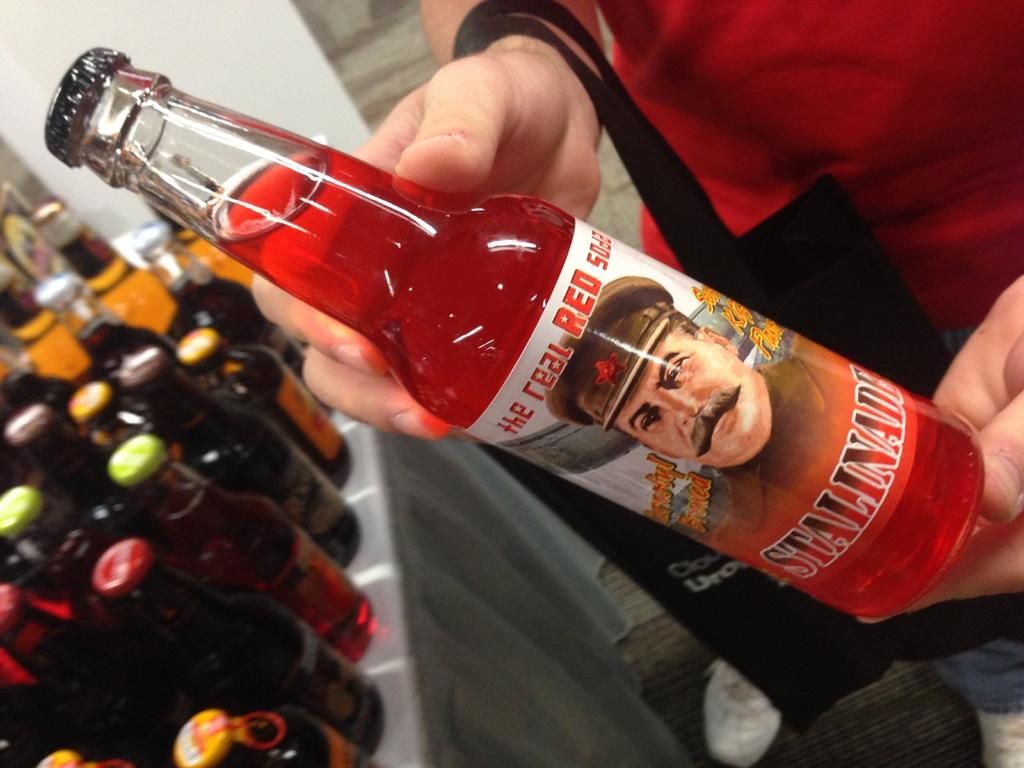What is the person in the image wearing? The person is wearing a red dress in the image. What is the person holding in the image? The person is holding a bottle in the image. What is inside the bottle the person is holding? The bottle contains a red drink. Where can additional bottles be found in the image? Additional bottles can be found on a table in the left corner of the image. What shape is the sponge used for cleaning the bottles in the image? There is no sponge present in the image, so it is not possible to determine its shape. 